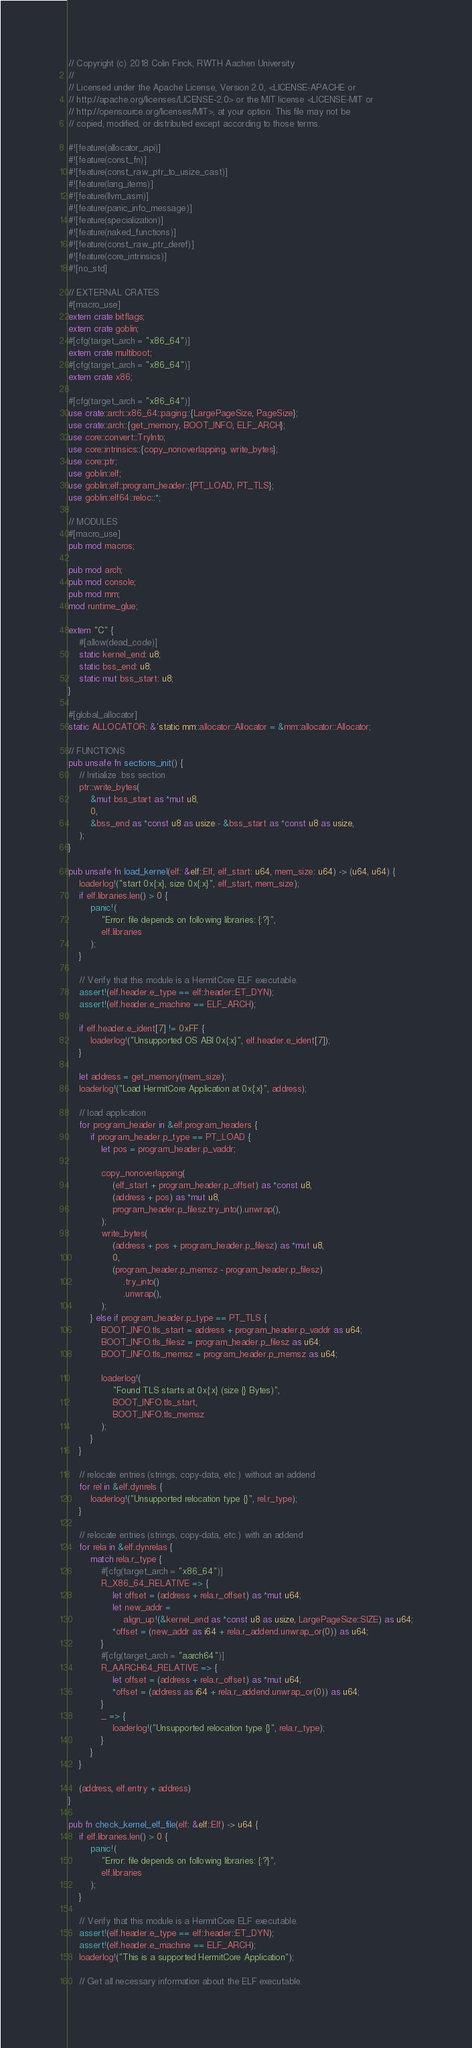Convert code to text. <code><loc_0><loc_0><loc_500><loc_500><_Rust_>// Copyright (c) 2018 Colin Finck, RWTH Aachen University
//
// Licensed under the Apache License, Version 2.0, <LICENSE-APACHE or
// http://apache.org/licenses/LICENSE-2.0> or the MIT license <LICENSE-MIT or
// http://opensource.org/licenses/MIT>, at your option. This file may not be
// copied, modified, or distributed except according to those terms.

#![feature(allocator_api)]
#![feature(const_fn)]
#![feature(const_raw_ptr_to_usize_cast)]
#![feature(lang_items)]
#![feature(llvm_asm)]
#![feature(panic_info_message)]
#![feature(specialization)]
#![feature(naked_functions)]
#![feature(const_raw_ptr_deref)]
#![feature(core_intrinsics)]
#![no_std]

// EXTERNAL CRATES
#[macro_use]
extern crate bitflags;
extern crate goblin;
#[cfg(target_arch = "x86_64")]
extern crate multiboot;
#[cfg(target_arch = "x86_64")]
extern crate x86;

#[cfg(target_arch = "x86_64")]
use crate::arch::x86_64::paging::{LargePageSize, PageSize};
use crate::arch::{get_memory, BOOT_INFO, ELF_ARCH};
use core::convert::TryInto;
use core::intrinsics::{copy_nonoverlapping, write_bytes};
use core::ptr;
use goblin::elf;
use goblin::elf::program_header::{PT_LOAD, PT_TLS};
use goblin::elf64::reloc::*;

// MODULES
#[macro_use]
pub mod macros;

pub mod arch;
pub mod console;
pub mod mm;
mod runtime_glue;

extern "C" {
	#[allow(dead_code)]
	static kernel_end: u8;
	static bss_end: u8;
	static mut bss_start: u8;
}

#[global_allocator]
static ALLOCATOR: &'static mm::allocator::Allocator = &mm::allocator::Allocator;

// FUNCTIONS
pub unsafe fn sections_init() {
	// Initialize .bss section
	ptr::write_bytes(
		&mut bss_start as *mut u8,
		0,
		&bss_end as *const u8 as usize - &bss_start as *const u8 as usize,
	);
}

pub unsafe fn load_kernel(elf: &elf::Elf, elf_start: u64, mem_size: u64) -> (u64, u64) {
	loaderlog!("start 0x{:x}, size 0x{:x}", elf_start, mem_size);
	if elf.libraries.len() > 0 {
		panic!(
			"Error: file depends on following libraries: {:?}",
			elf.libraries
		);
	}

	// Verify that this module is a HermitCore ELF executable.
	assert!(elf.header.e_type == elf::header::ET_DYN);
	assert!(elf.header.e_machine == ELF_ARCH);

	if elf.header.e_ident[7] != 0xFF {
		loaderlog!("Unsupported OS ABI 0x{:x}", elf.header.e_ident[7]);
	}

	let address = get_memory(mem_size);
	loaderlog!("Load HermitCore Application at 0x{:x}", address);

	// load application
	for program_header in &elf.program_headers {
		if program_header.p_type == PT_LOAD {
			let pos = program_header.p_vaddr;

			copy_nonoverlapping(
				(elf_start + program_header.p_offset) as *const u8,
				(address + pos) as *mut u8,
				program_header.p_filesz.try_into().unwrap(),
			);
			write_bytes(
				(address + pos + program_header.p_filesz) as *mut u8,
				0,
				(program_header.p_memsz - program_header.p_filesz)
					.try_into()
					.unwrap(),
			);
		} else if program_header.p_type == PT_TLS {
			BOOT_INFO.tls_start = address + program_header.p_vaddr as u64;
			BOOT_INFO.tls_filesz = program_header.p_filesz as u64;
			BOOT_INFO.tls_memsz = program_header.p_memsz as u64;

			loaderlog!(
				"Found TLS starts at 0x{:x} (size {} Bytes)",
				BOOT_INFO.tls_start,
				BOOT_INFO.tls_memsz
			);
		}
	}

	// relocate entries (strings, copy-data, etc.) without an addend
	for rel in &elf.dynrels {
		loaderlog!("Unsupported relocation type {}", rel.r_type);
	}

	// relocate entries (strings, copy-data, etc.) with an addend
	for rela in &elf.dynrelas {
		match rela.r_type {
			#[cfg(target_arch = "x86_64")]
			R_X86_64_RELATIVE => {
				let offset = (address + rela.r_offset) as *mut u64;
				let new_addr =
					align_up!(&kernel_end as *const u8 as usize, LargePageSize::SIZE) as u64;
				*offset = (new_addr as i64 + rela.r_addend.unwrap_or(0)) as u64;
			}
			#[cfg(target_arch = "aarch64")]
			R_AARCH64_RELATIVE => {
				let offset = (address + rela.r_offset) as *mut u64;
				*offset = (address as i64 + rela.r_addend.unwrap_or(0)) as u64;
			}
			_ => {
				loaderlog!("Unsupported relocation type {}", rela.r_type);
			}
		}
	}

	(address, elf.entry + address)
}

pub fn check_kernel_elf_file(elf: &elf::Elf) -> u64 {
	if elf.libraries.len() > 0 {
		panic!(
			"Error: file depends on following libraries: {:?}",
			elf.libraries
		);
	}

	// Verify that this module is a HermitCore ELF executable.
	assert!(elf.header.e_type == elf::header::ET_DYN);
	assert!(elf.header.e_machine == ELF_ARCH);
	loaderlog!("This is a supported HermitCore Application");

	// Get all necessary information about the ELF executable.</code> 